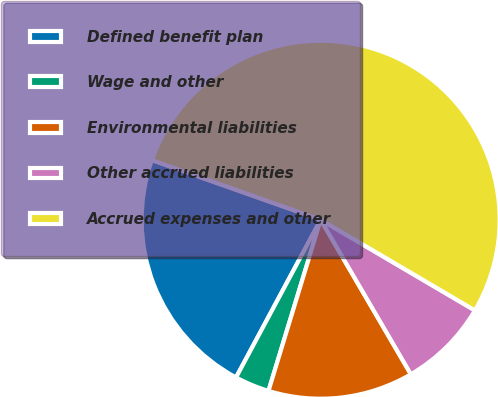Convert chart to OTSL. <chart><loc_0><loc_0><loc_500><loc_500><pie_chart><fcel>Defined benefit plan<fcel>Wage and other<fcel>Environmental liabilities<fcel>Other accrued liabilities<fcel>Accrued expenses and other<nl><fcel>22.57%<fcel>3.13%<fcel>13.12%<fcel>8.13%<fcel>53.05%<nl></chart> 